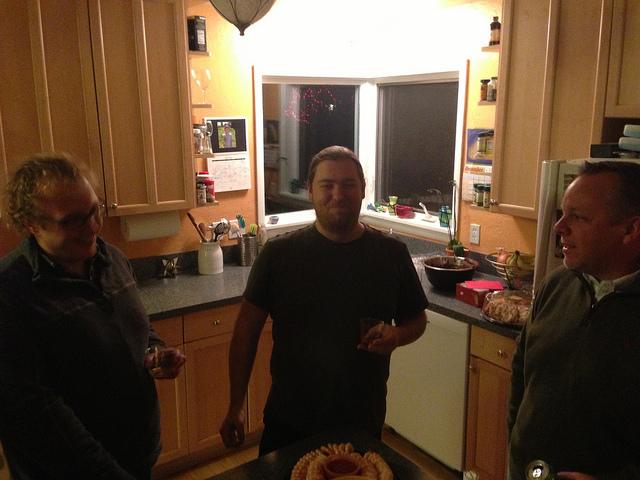Is the man in the middle smiling?
Answer briefly. Yes. What is in the white jar on the countertop?
Give a very brief answer. Utensils. How many men are in this picture?
Quick response, please. 3. 